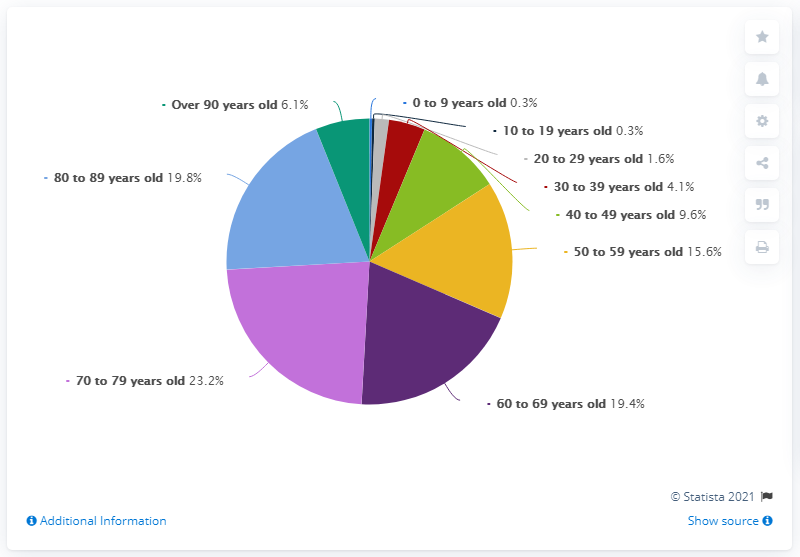Identify some key points in this picture. In the United States, approximately 25.9% of people over the age of 80 were hospitalized in 2019, according to recent data. In the age group of 20 to 29 years old, there were the third least number of hospitalizations. 